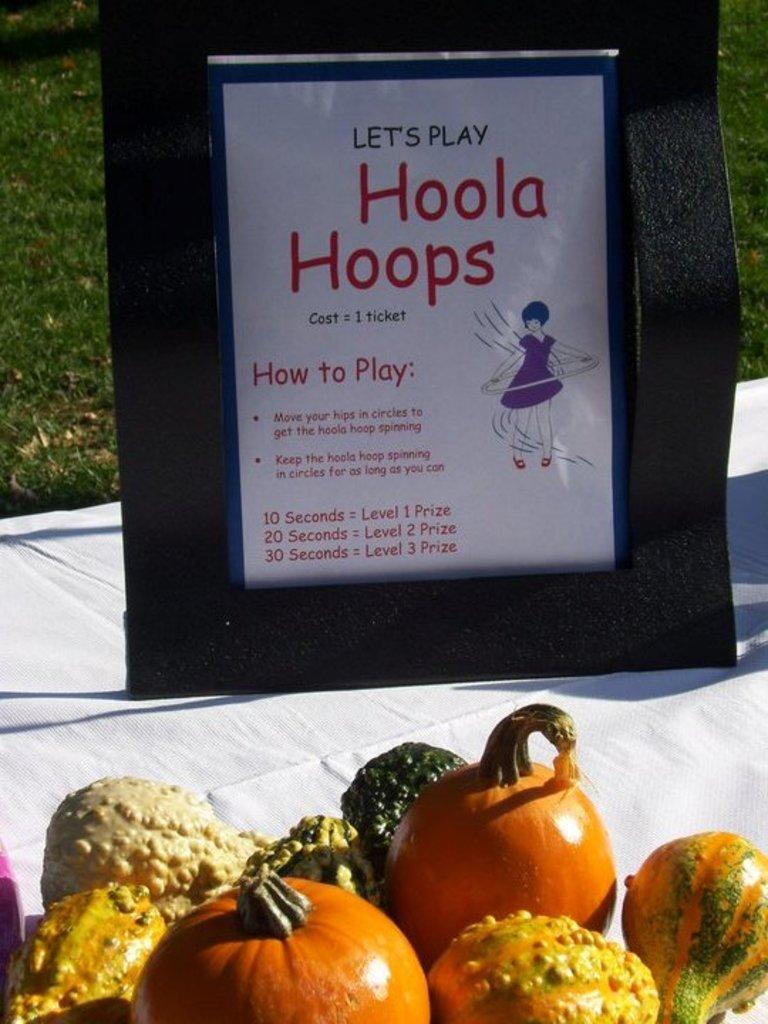Describe this image in one or two sentences. In this picture I can observe a photo frame. There is some text in this photo frame. On the bottom of the picture I can observe some vegetables. In the background there is some grass on the ground. 